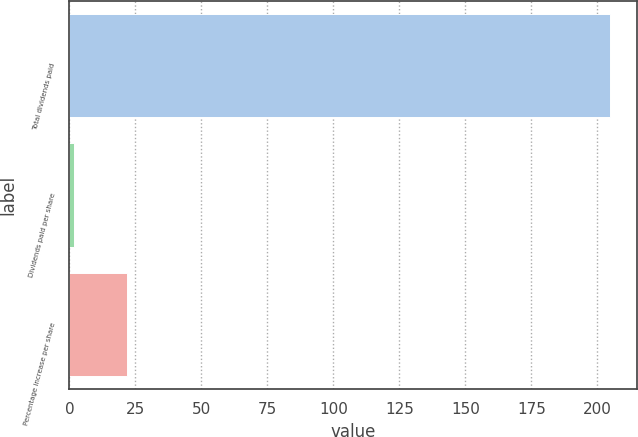Convert chart. <chart><loc_0><loc_0><loc_500><loc_500><bar_chart><fcel>Total dividends paid<fcel>Dividends paid per share<fcel>Percentage increase per share<nl><fcel>204.9<fcel>1.6<fcel>21.93<nl></chart> 